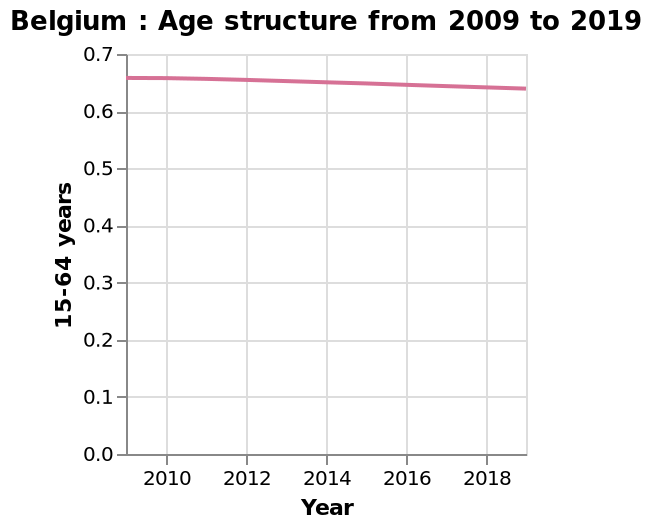<image>
Who does the age range of 15-64 refer to?  The age range of 15-64 refers to people between the ages of 15 and 64. What does the y-axis represent in the line diagram?  The y-axis represents the scale for the age group of 15-64 years, ranging from 0.0 to 0.7. 